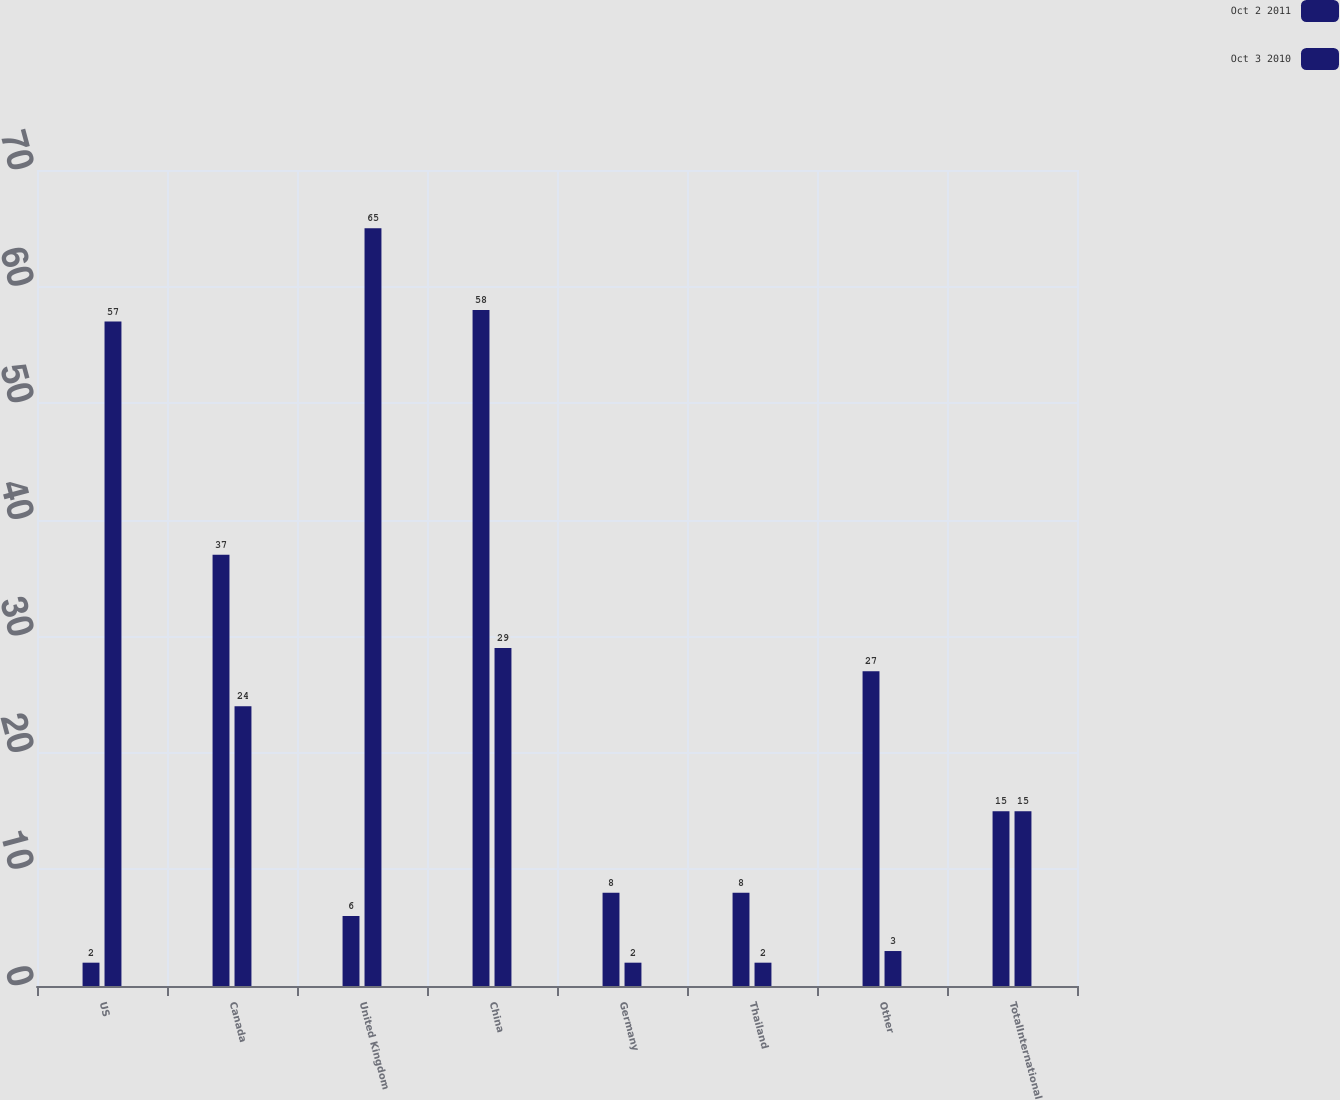Convert chart to OTSL. <chart><loc_0><loc_0><loc_500><loc_500><stacked_bar_chart><ecel><fcel>US<fcel>Canada<fcel>United Kingdom<fcel>China<fcel>Germany<fcel>Thailand<fcel>Other<fcel>TotalInternational<nl><fcel>Oct 2 2011<fcel>2<fcel>37<fcel>6<fcel>58<fcel>8<fcel>8<fcel>27<fcel>15<nl><fcel>Oct 3 2010<fcel>57<fcel>24<fcel>65<fcel>29<fcel>2<fcel>2<fcel>3<fcel>15<nl></chart> 